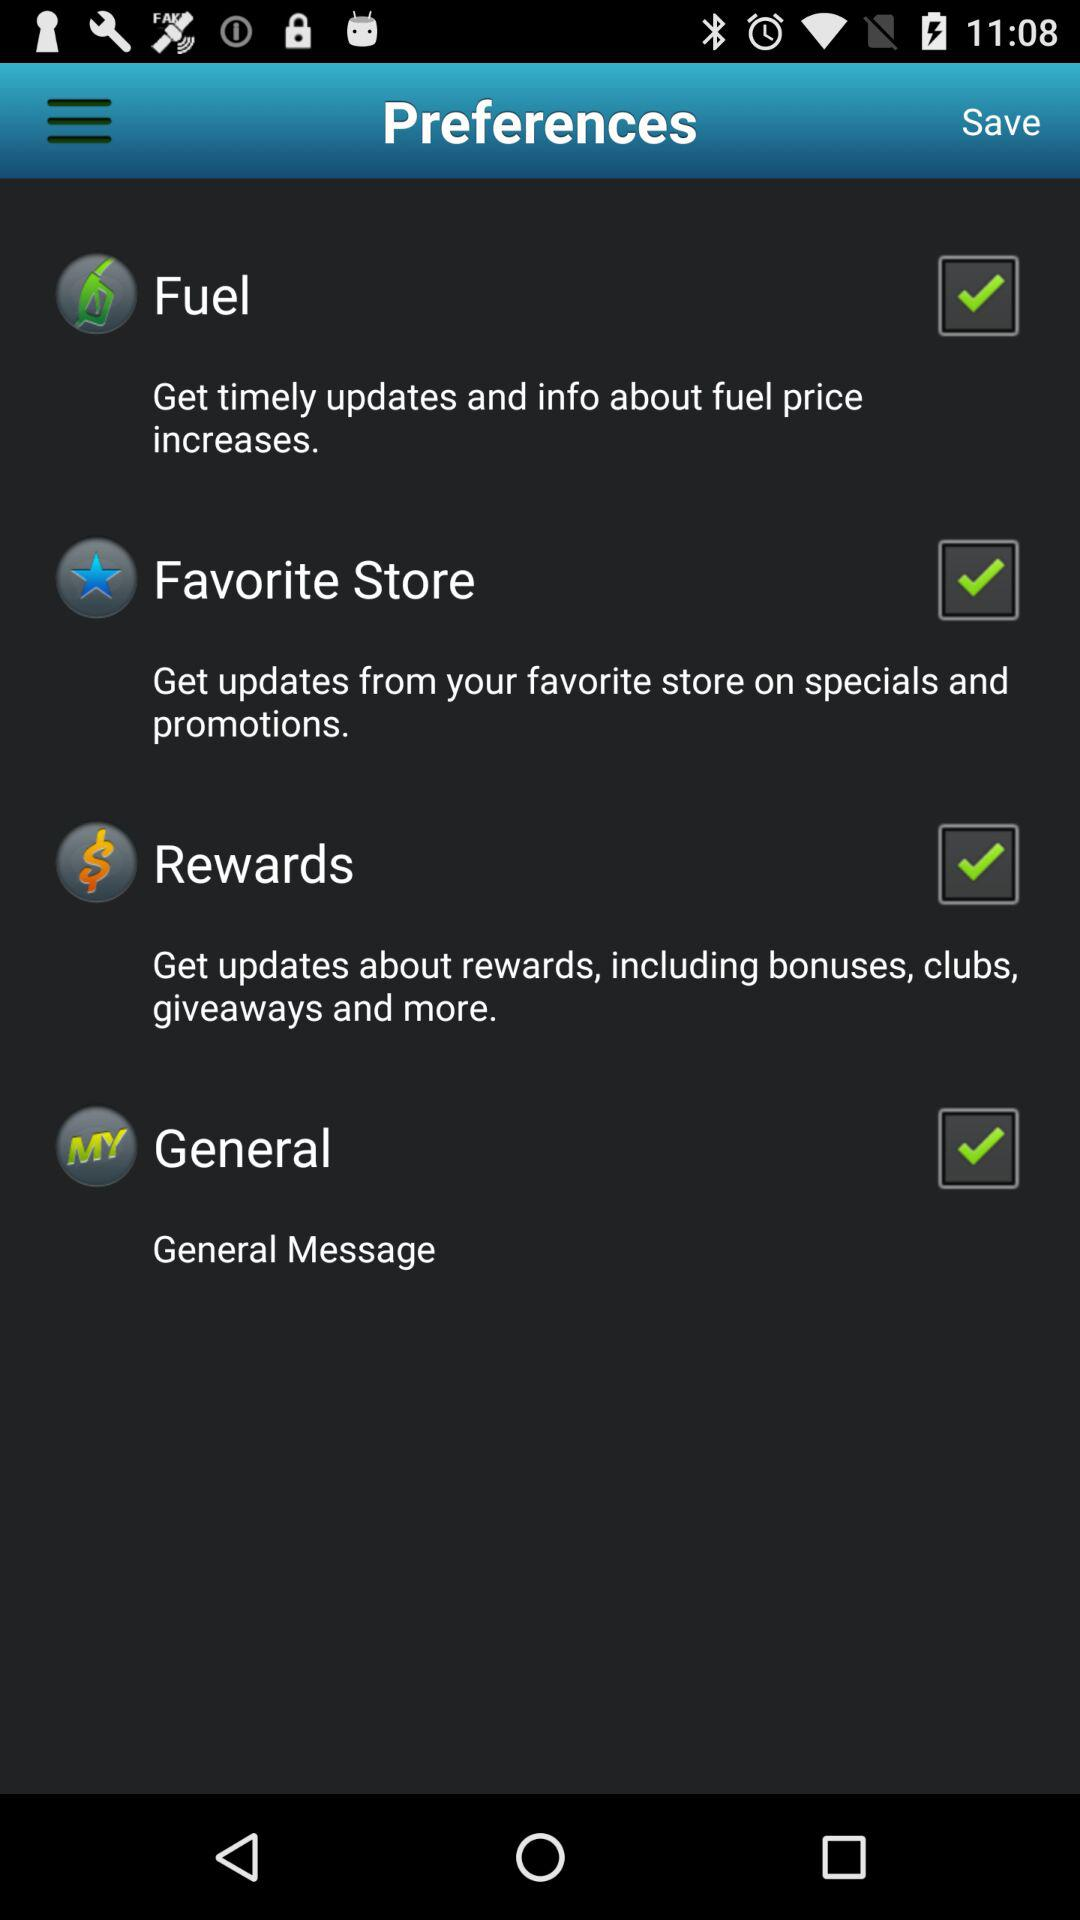Which option is checked? The checked options are "Fuel", "Favorite Store", "Rewards" and "General". 